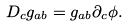<formula> <loc_0><loc_0><loc_500><loc_500>D _ { c } g _ { a b } = g _ { a b } \partial _ { c } \phi .</formula> 